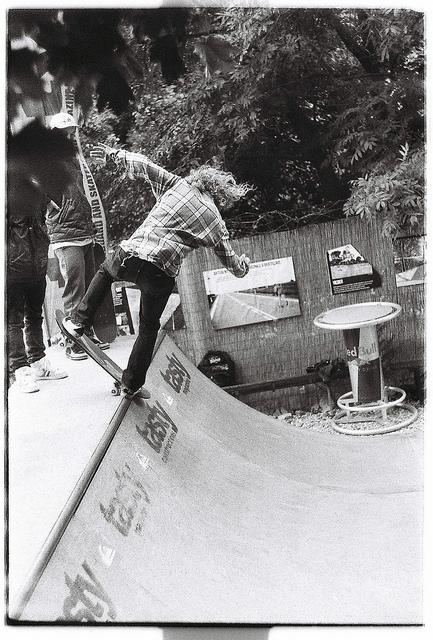Is there a half pipe in this picture?
Short answer required. Yes. Does the human has short hair?
Concise answer only. No. Is the picture black and white?
Write a very short answer. Yes. 